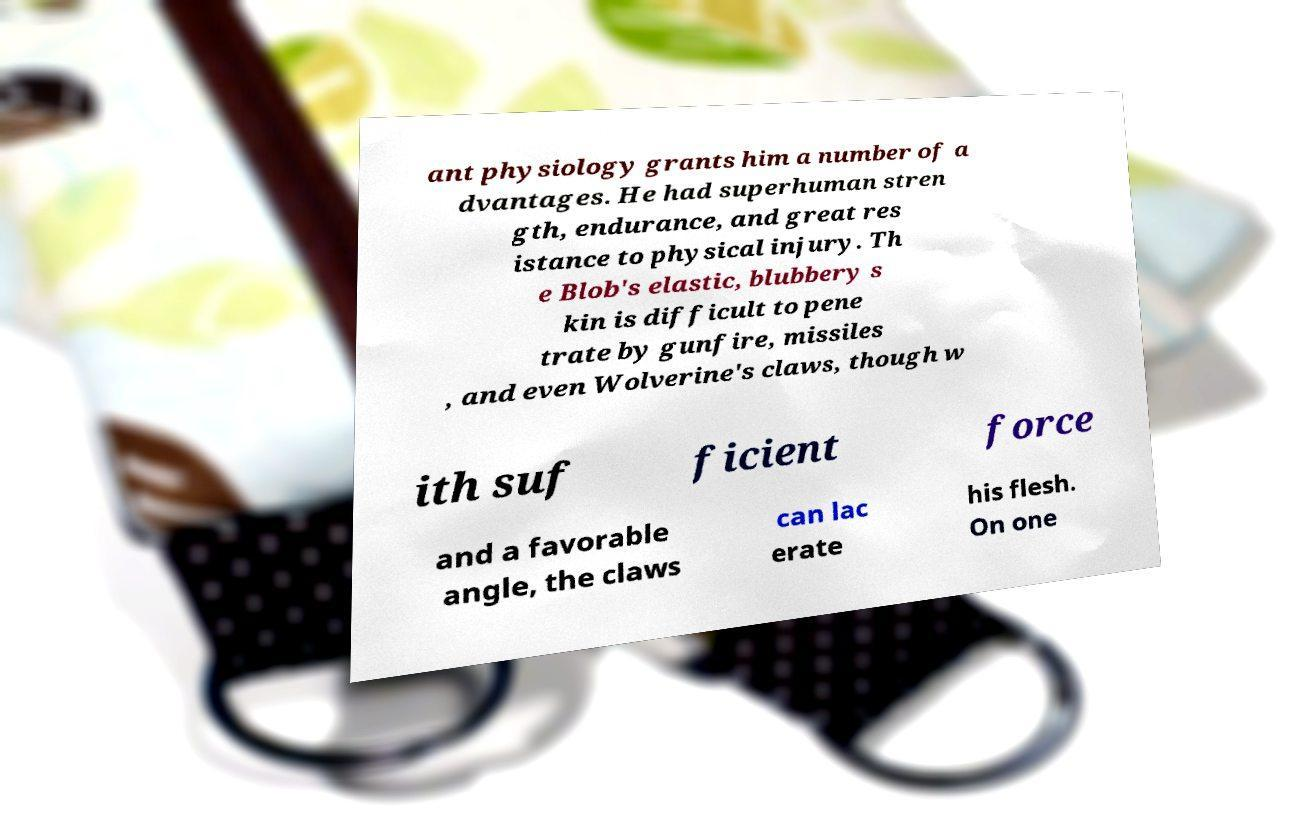There's text embedded in this image that I need extracted. Can you transcribe it verbatim? ant physiology grants him a number of a dvantages. He had superhuman stren gth, endurance, and great res istance to physical injury. Th e Blob's elastic, blubbery s kin is difficult to pene trate by gunfire, missiles , and even Wolverine's claws, though w ith suf ficient force and a favorable angle, the claws can lac erate his flesh. On one 